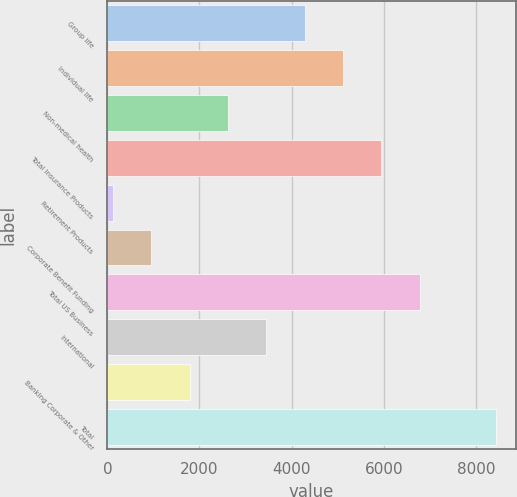Convert chart. <chart><loc_0><loc_0><loc_500><loc_500><bar_chart><fcel>Group life<fcel>Individual life<fcel>Non-medical health<fcel>Total Insurance Products<fcel>Retirement Products<fcel>Corporate Benefit Funding<fcel>Total US Business<fcel>International<fcel>Banking Corporate & Other<fcel>Total<nl><fcel>4284<fcel>5116.4<fcel>2619.2<fcel>5948.8<fcel>122<fcel>954.4<fcel>6781.2<fcel>3451.6<fcel>1786.8<fcel>8446<nl></chart> 